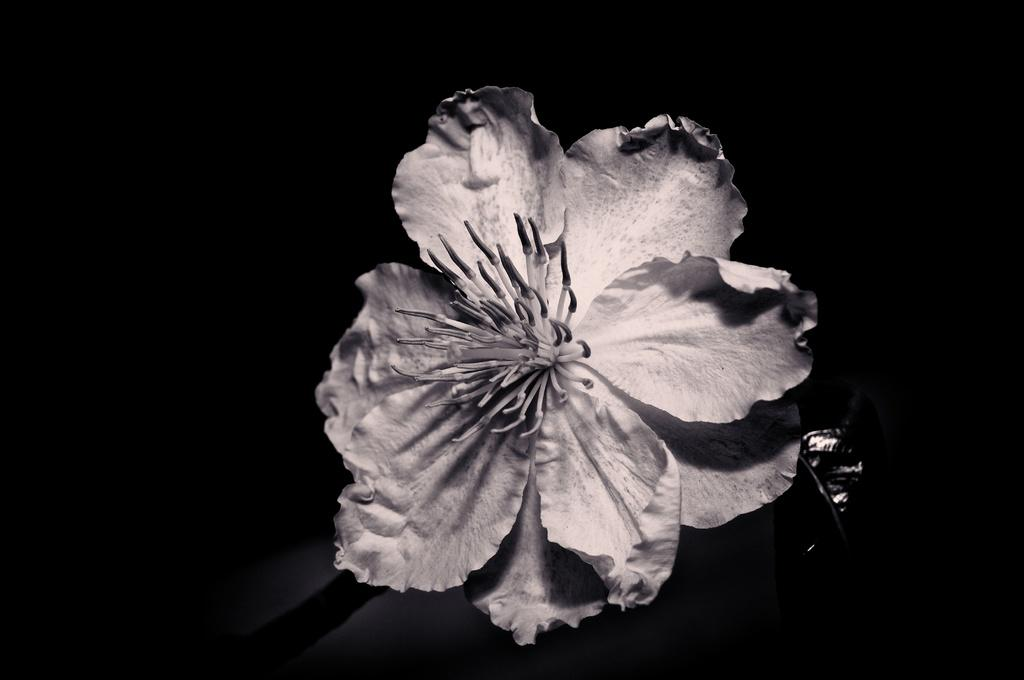What is the color scheme of the image? The image is black and white. What is the main subject of the image? There is a flower in the image. What color is the background of the image? The background of the image is black. Can you hear the flower laughing in the image? There is no sound or laughter in the image, as it is a still, black and white photograph of a flower. 